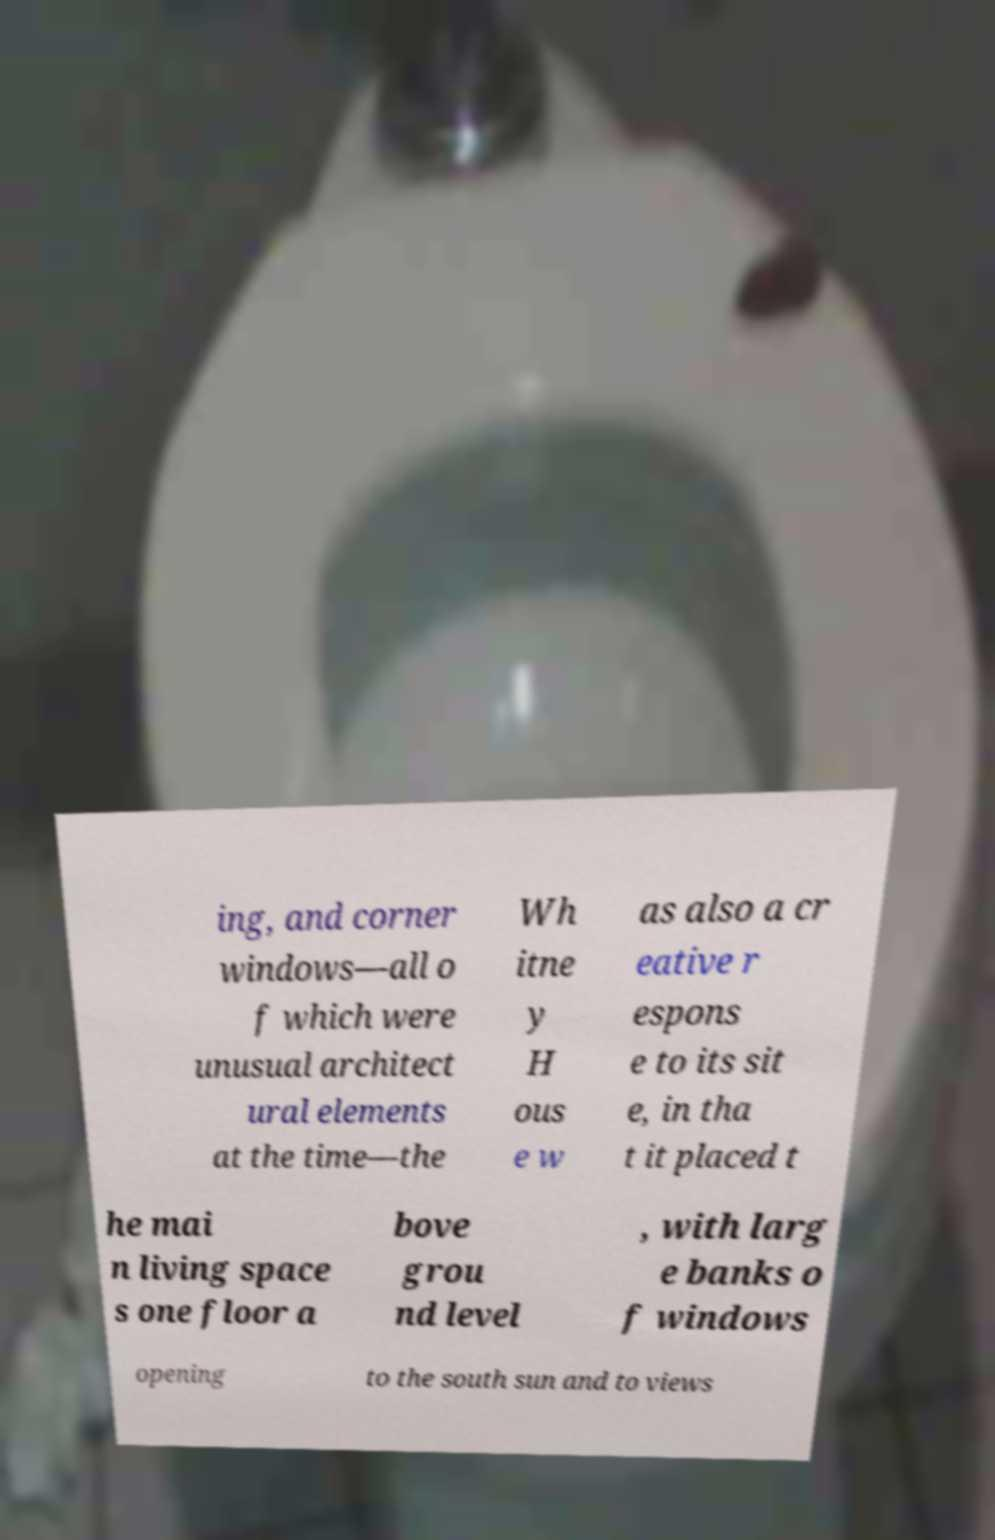For documentation purposes, I need the text within this image transcribed. Could you provide that? ing, and corner windows—all o f which were unusual architect ural elements at the time—the Wh itne y H ous e w as also a cr eative r espons e to its sit e, in tha t it placed t he mai n living space s one floor a bove grou nd level , with larg e banks o f windows opening to the south sun and to views 